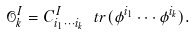Convert formula to latex. <formula><loc_0><loc_0><loc_500><loc_500>\mathcal { O } _ { k } ^ { I } = C _ { i _ { 1 } \cdots i _ { k } } ^ { I } \ t r ( \phi ^ { i _ { 1 } } \cdots \phi ^ { i _ { k } } ) .</formula> 